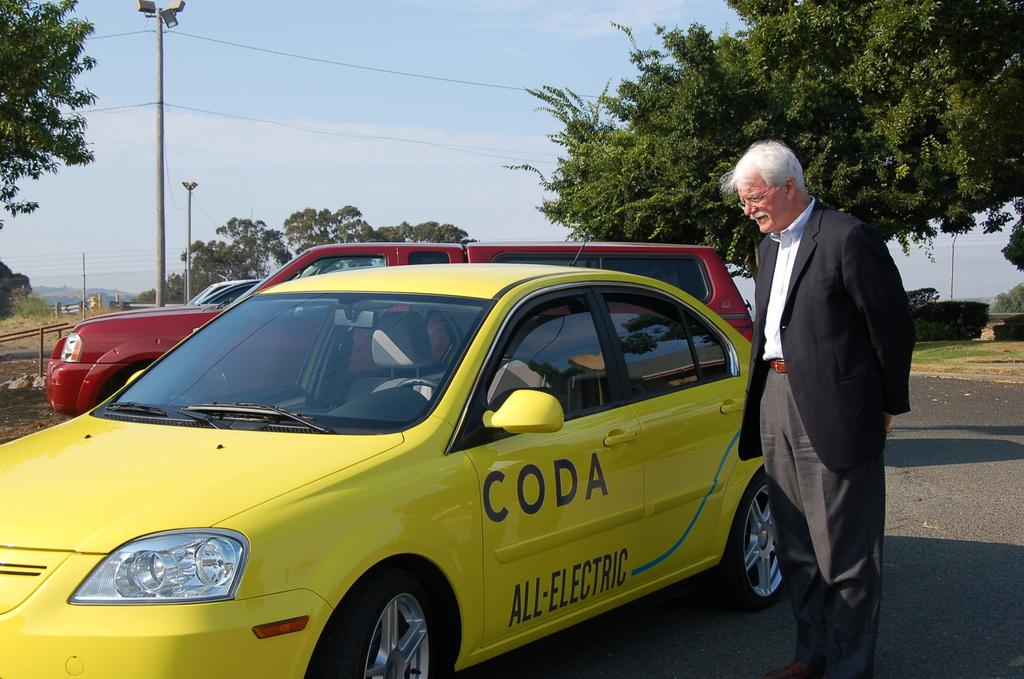Provide a one-sentence caption for the provided image. A man looks at a yellow car that is all electric and made by CODA. 